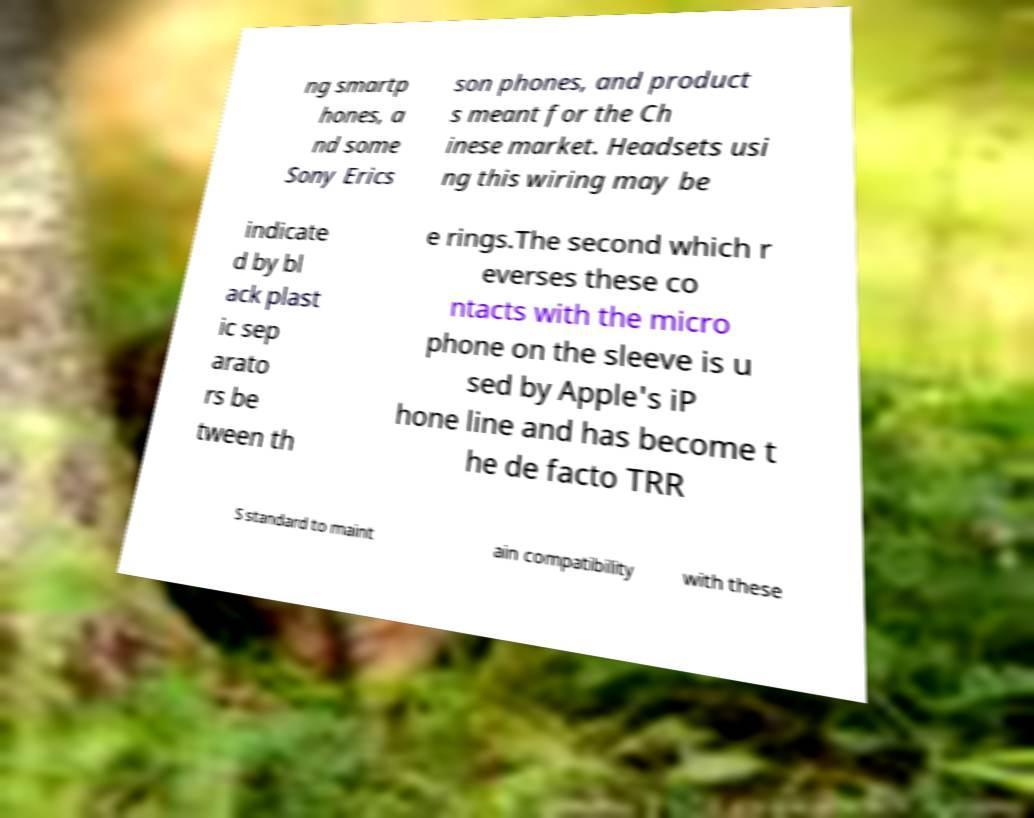Could you extract and type out the text from this image? ng smartp hones, a nd some Sony Erics son phones, and product s meant for the Ch inese market. Headsets usi ng this wiring may be indicate d by bl ack plast ic sep arato rs be tween th e rings.The second which r everses these co ntacts with the micro phone on the sleeve is u sed by Apple's iP hone line and has become t he de facto TRR S standard to maint ain compatibility with these 